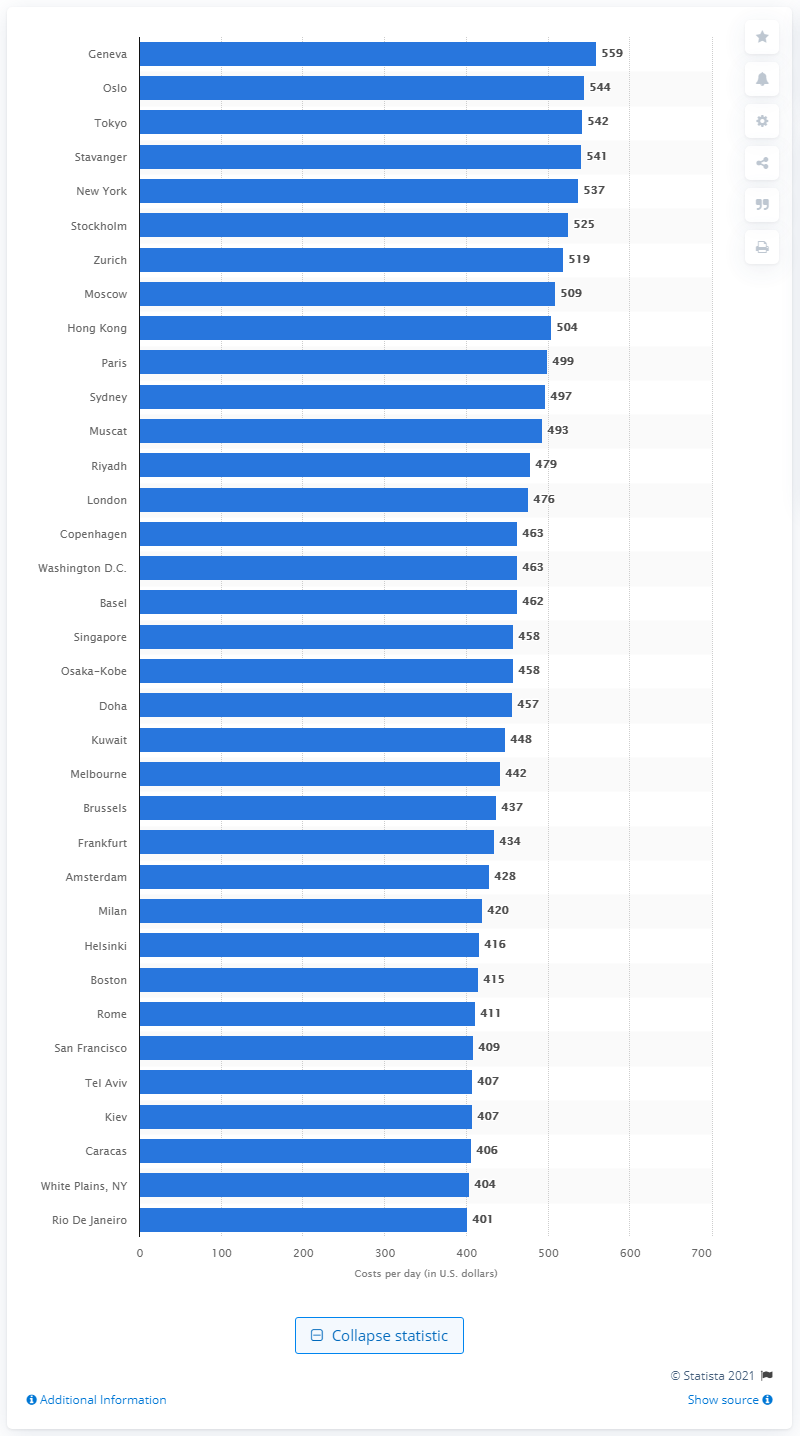Mention a couple of crucial points in this snapshot. In 2011, Geneva was ranked as the most expensive city in the world. In 2011, Geneva spent an average of $559 per day. 